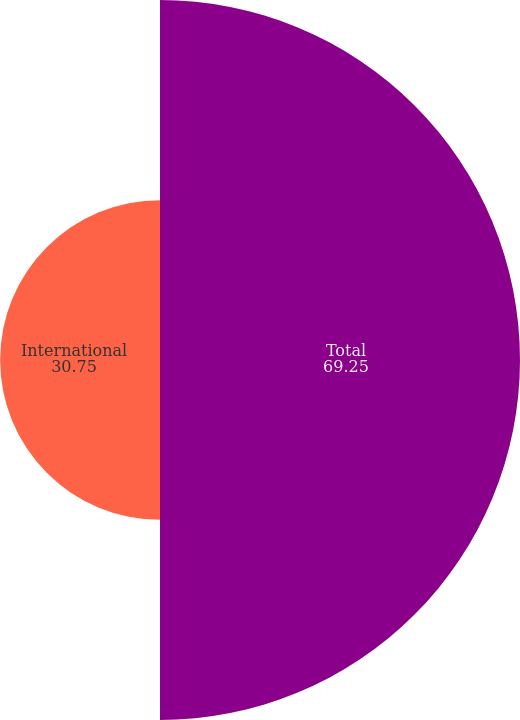Convert chart. <chart><loc_0><loc_0><loc_500><loc_500><pie_chart><fcel>Total<fcel>International<nl><fcel>69.25%<fcel>30.75%<nl></chart> 